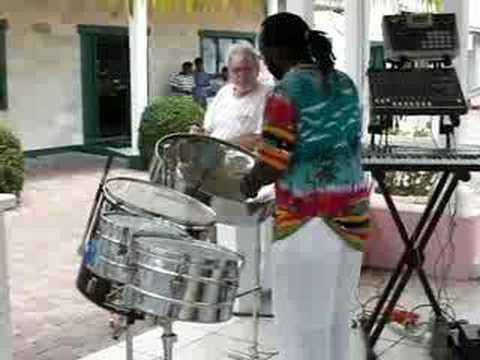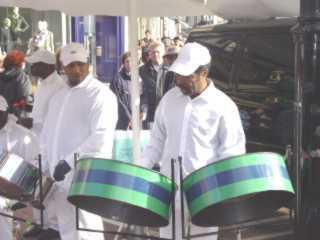The first image is the image on the left, the second image is the image on the right. For the images displayed, is the sentence "The left image features only man in a hawaiian shirt who is playing a silver-colored drum." factually correct? Answer yes or no. Yes. The first image is the image on the left, the second image is the image on the right. Given the left and right images, does the statement "The left and right image contains seven drums." hold true? Answer yes or no. Yes. 